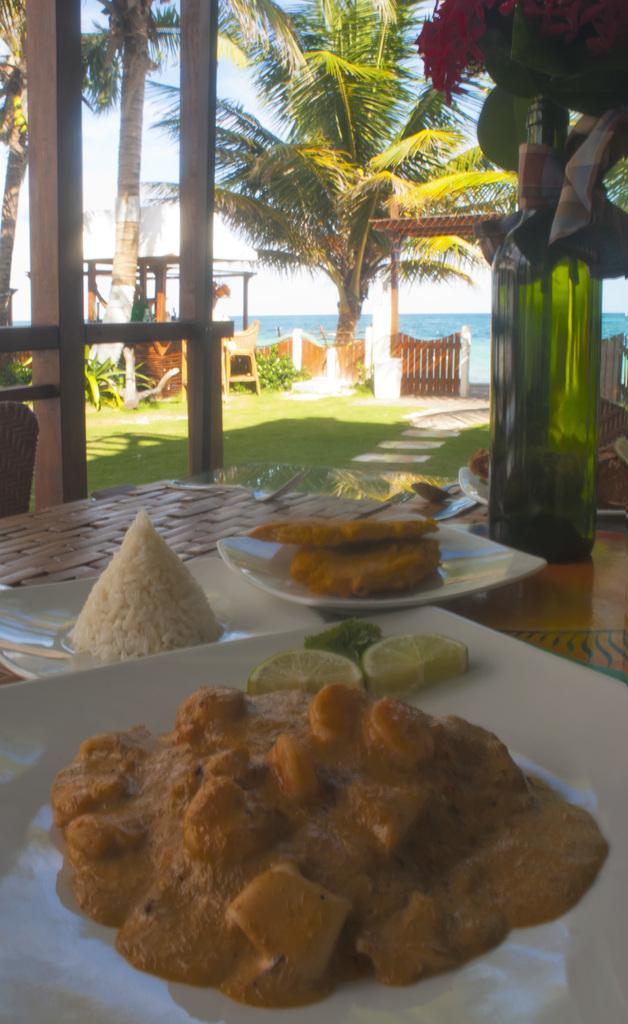Describe this image in one or two sentences. In this image we can see some food in the plates and a bottle with flowers which are placed on the table. On the backside we can see some wooden poles, fence, grass, a tree, a water body, a roof and the sky. 